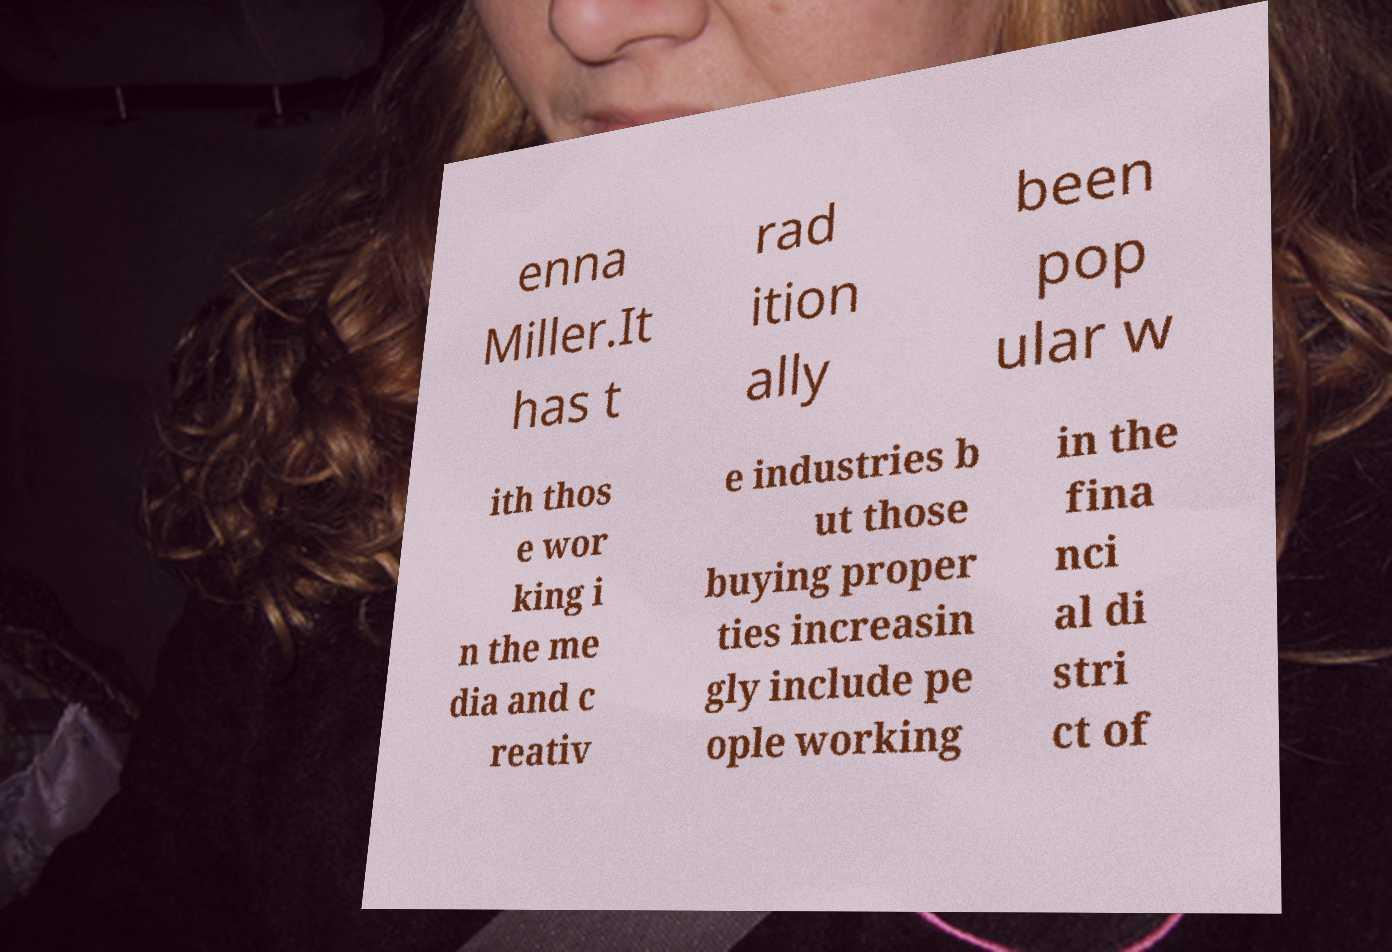What messages or text are displayed in this image? I need them in a readable, typed format. enna Miller.It has t rad ition ally been pop ular w ith thos e wor king i n the me dia and c reativ e industries b ut those buying proper ties increasin gly include pe ople working in the fina nci al di stri ct of 